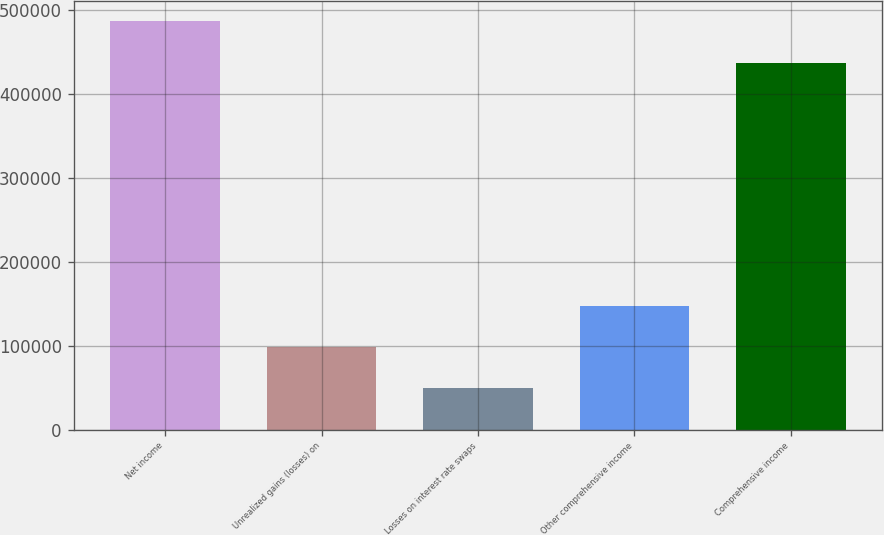<chart> <loc_0><loc_0><loc_500><loc_500><bar_chart><fcel>Net income<fcel>Unrealized gains (losses) on<fcel>Losses on interest rate swaps<fcel>Other comprehensive income<fcel>Comprehensive income<nl><fcel>486532<fcel>98363.8<fcel>49292.4<fcel>147435<fcel>437461<nl></chart> 